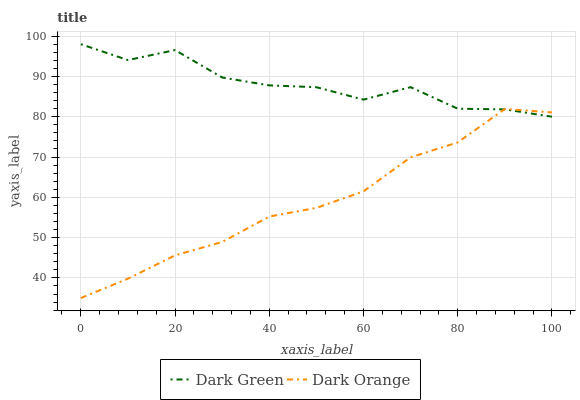Does Dark Orange have the minimum area under the curve?
Answer yes or no. Yes. Does Dark Green have the maximum area under the curve?
Answer yes or no. Yes. Does Dark Green have the minimum area under the curve?
Answer yes or no. No. Is Dark Orange the smoothest?
Answer yes or no. Yes. Is Dark Green the roughest?
Answer yes or no. Yes. Is Dark Green the smoothest?
Answer yes or no. No. Does Dark Orange have the lowest value?
Answer yes or no. Yes. Does Dark Green have the lowest value?
Answer yes or no. No. Does Dark Green have the highest value?
Answer yes or no. Yes. Does Dark Orange intersect Dark Green?
Answer yes or no. Yes. Is Dark Orange less than Dark Green?
Answer yes or no. No. Is Dark Orange greater than Dark Green?
Answer yes or no. No. 